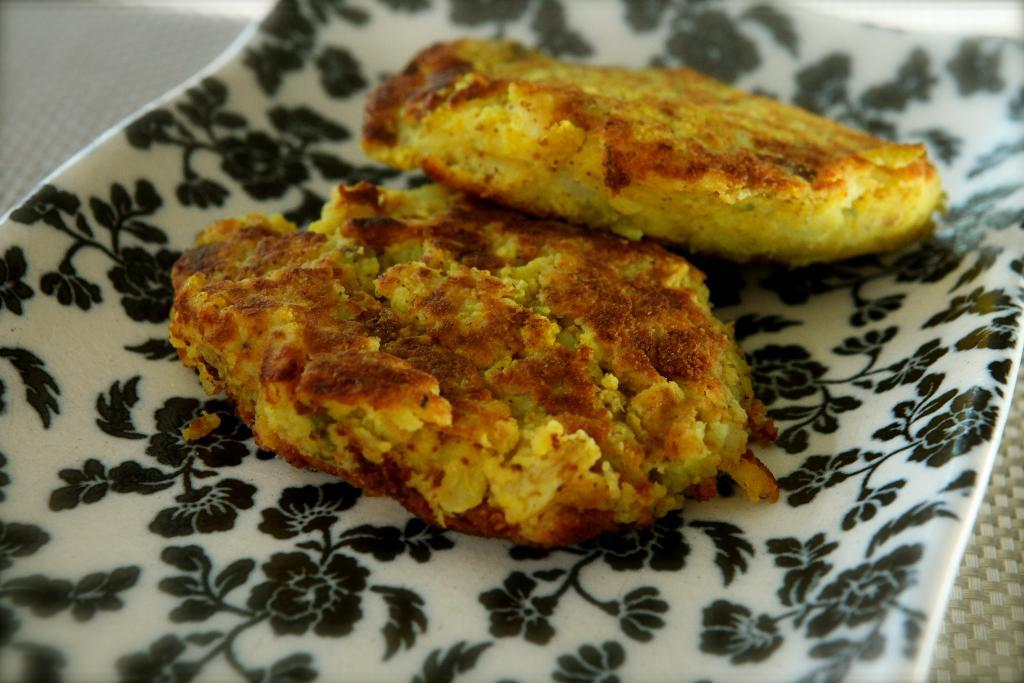What is the main object in the center of the image? There is a cloth in the center of the image. What is placed on the cloth? There is a plate on the cloth. What can be found on the plate? There are food items in the plate. How many jellyfish can be seen swimming near the coast in the image? There are no jellyfish or coast visible in the image; it features a cloth, a plate, and food items. 